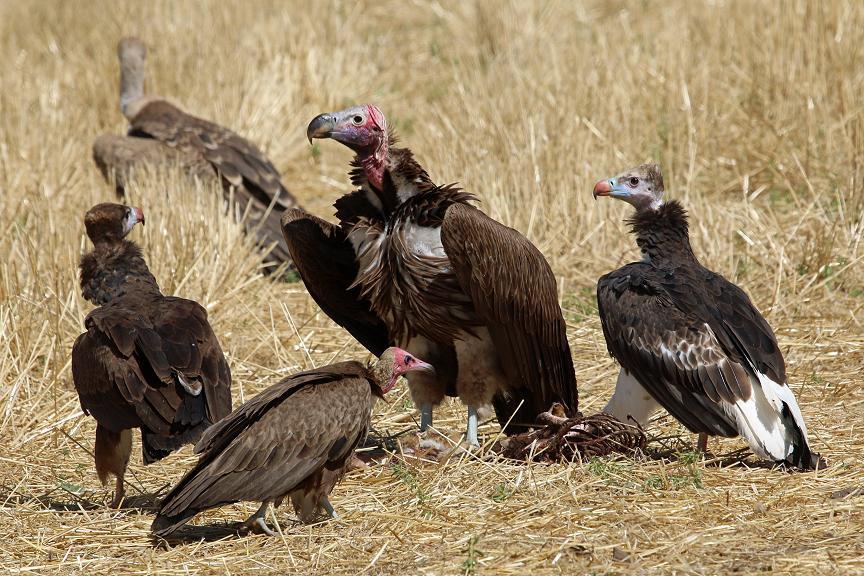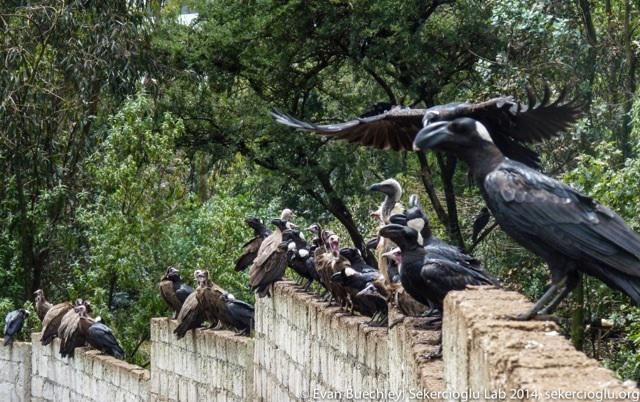The first image is the image on the left, the second image is the image on the right. Considering the images on both sides, is "An image shows one dark bird perched on a horizontal tree branch." valid? Answer yes or no. No. The first image is the image on the left, the second image is the image on the right. Analyze the images presented: Is the assertion "Large groups of vultures are gathered on walls of wood or brick in one of the images." valid? Answer yes or no. Yes. The first image is the image on the left, the second image is the image on the right. For the images shown, is this caption "One of the images shows exactly one bird perched on a branch." true? Answer yes or no. No. The first image is the image on the left, the second image is the image on the right. Considering the images on both sides, is "There are at most three ravens standing on a branch" valid? Answer yes or no. No. 